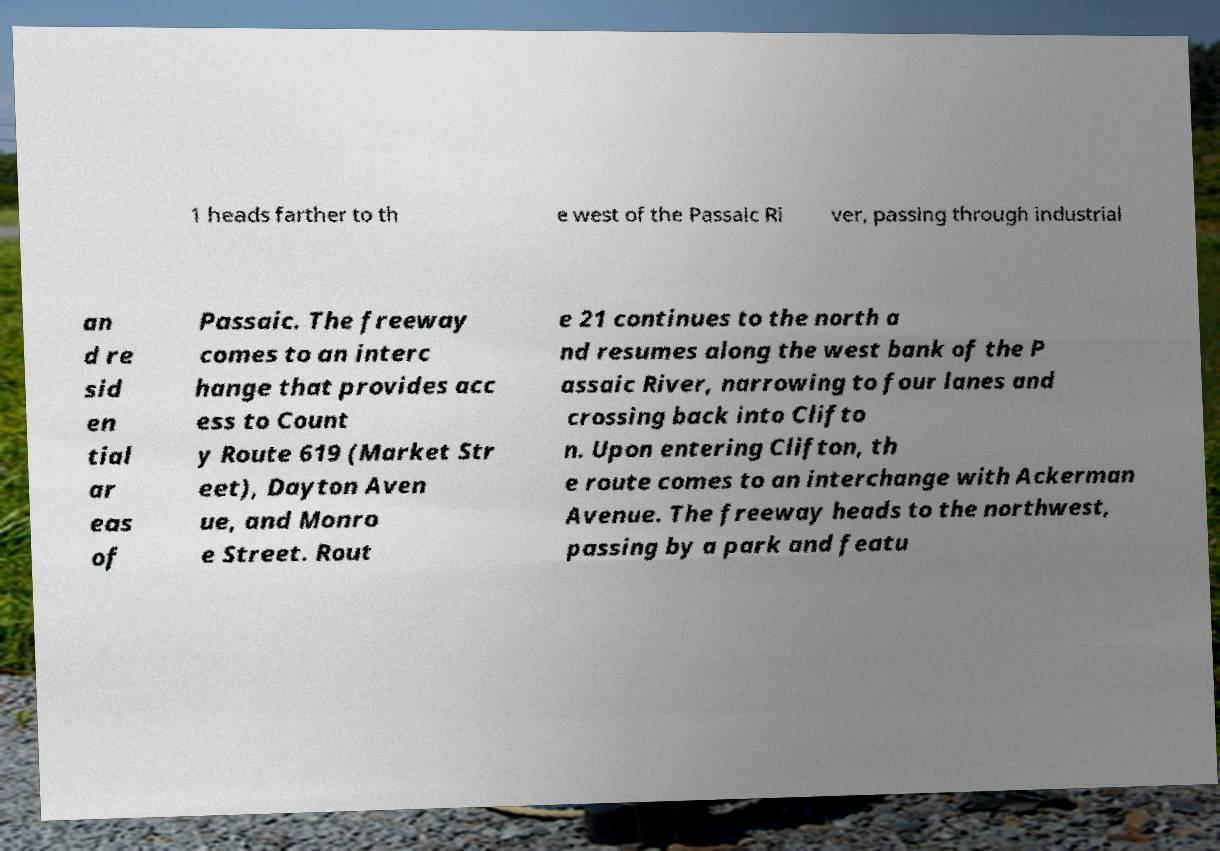Can you read and provide the text displayed in the image?This photo seems to have some interesting text. Can you extract and type it out for me? 1 heads farther to th e west of the Passaic Ri ver, passing through industrial an d re sid en tial ar eas of Passaic. The freeway comes to an interc hange that provides acc ess to Count y Route 619 (Market Str eet), Dayton Aven ue, and Monro e Street. Rout e 21 continues to the north a nd resumes along the west bank of the P assaic River, narrowing to four lanes and crossing back into Clifto n. Upon entering Clifton, th e route comes to an interchange with Ackerman Avenue. The freeway heads to the northwest, passing by a park and featu 